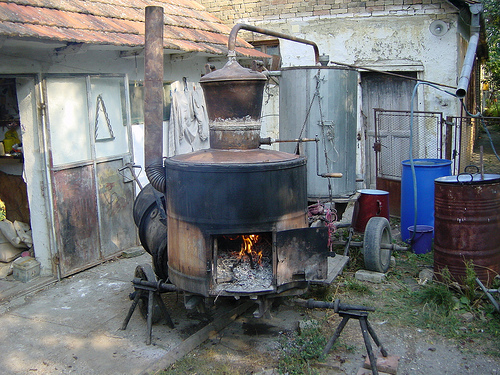<image>
Can you confirm if the door is behind the fence? Yes. From this viewpoint, the door is positioned behind the fence, with the fence partially or fully occluding the door. 